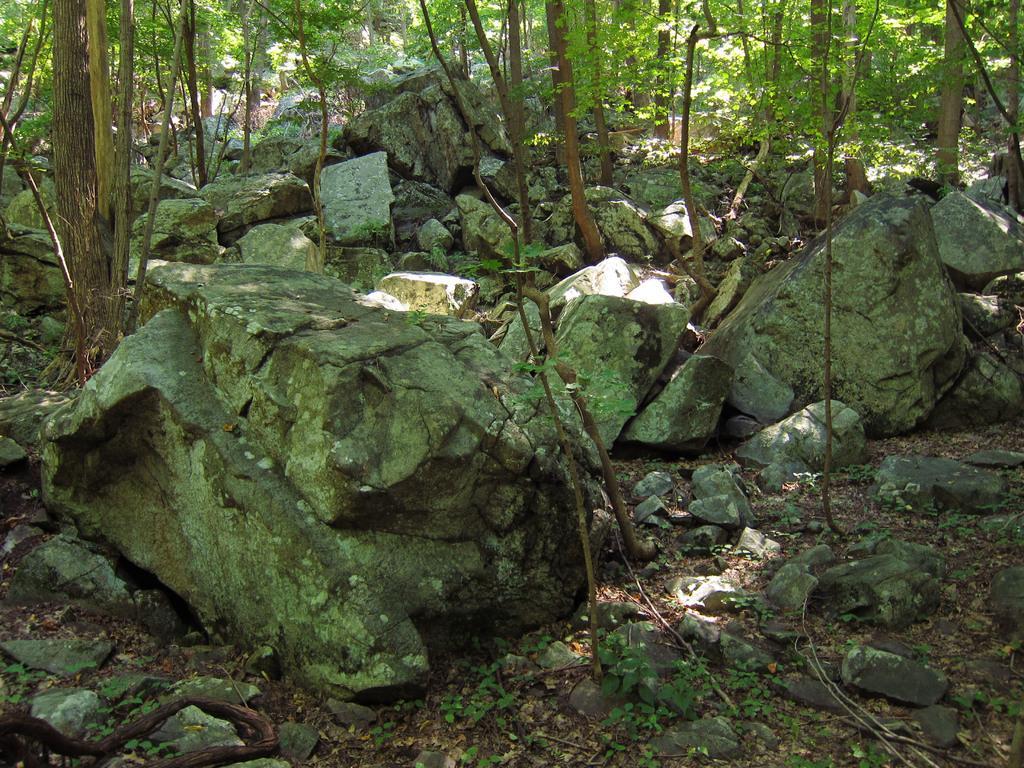Could you give a brief overview of what you see in this image? In this picture I can see rocks, plants and trees. 